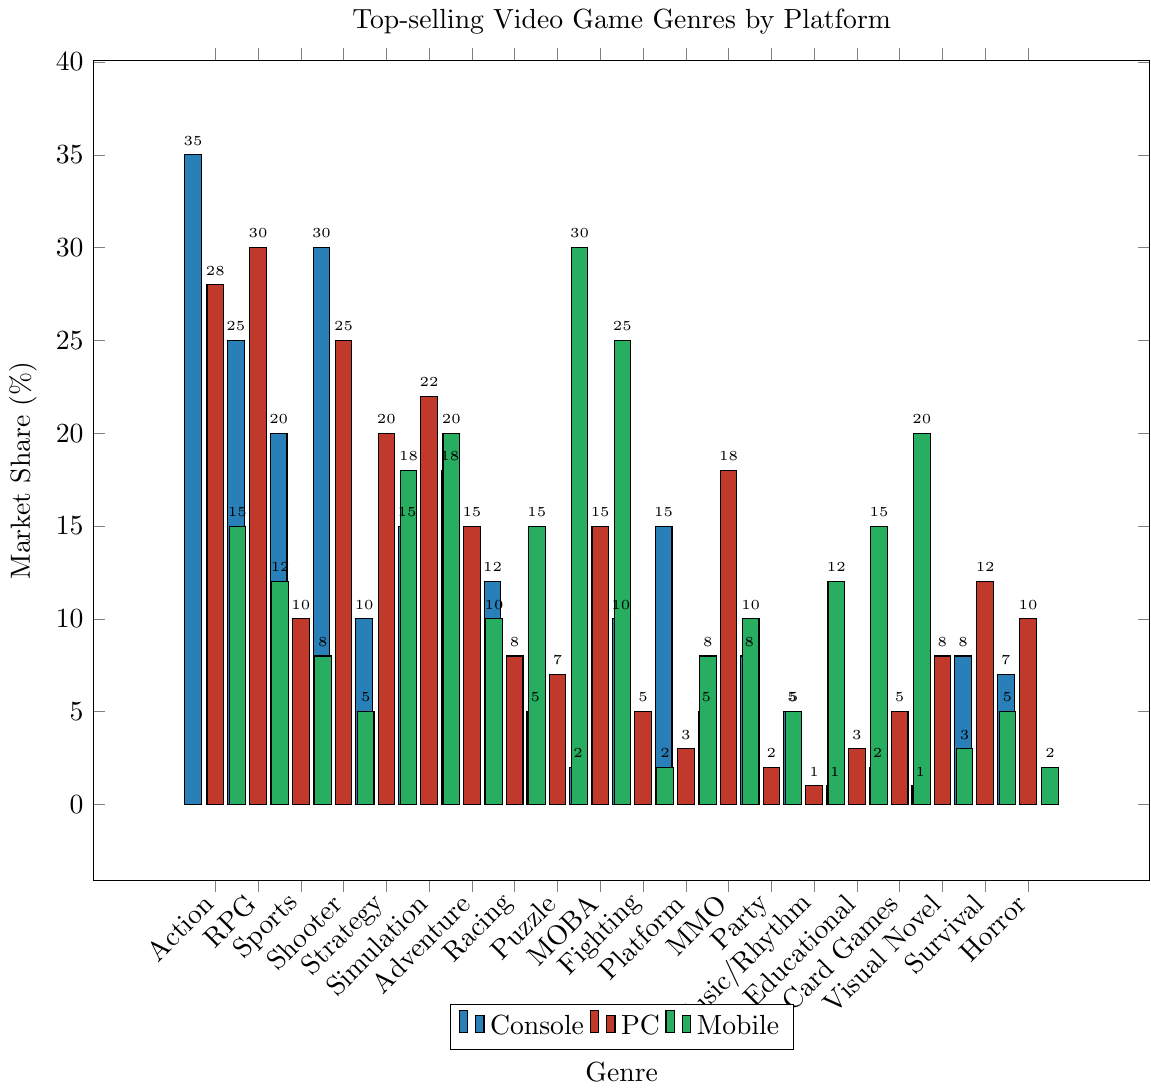What's the difference in market share for the "Action" genre between Console and Mobile platforms? The market share for the "Action" genre on Console is 35%, while on Mobile it is 15%. The difference is calculated as 35% - 15%.
Answer: 20% Which genre has the highest market share on Mobile? By observing the heights of the bars for Mobile across all genres, "Puzzle" has the highest market share with 30%.
Answer: Puzzle How many genres have a higher market share on PC than on Console? By comparing the heights of the bars for PC and Console for each genre, the genres with a higher market share on PC are RPG, Strategy, Simulation, MMO, MOBA, Visual Novel, and Horror. The total count of these genres is 7.
Answer: 7 What's the average market share of the "Sports" genre across all platforms? The market shares for "Sports" on Console, PC, and Mobile are 20%, 10%, and 8% respectively. The average is calculated as (20 + 10 + 8) / 3.
Answer: 12.67% Is the market share of the "Fighting" genre on Console higher, lower, or equal to the share of the "MOBA" genre on Mobile? The market share for the "Fighting" genre on Console is 10%, while for the "MOBA" genre on Mobile it is 25%. Comparing these values, 10% is less than 25%.
Answer: Lower Which genre has the lowest market share on Console? By observing the heights of the bars for Console, "Educational" has the lowest market share at 1%.
Answer: Educational What is the sum of market shares of the "Simulation" genre on Console and PC? The market shares for "Simulation" on Console and PC are 15% and 22% respectively. The sum is calculated as 15% + 22%.
Answer: 37% For which genre is the difference in market share between Mobile and PC the greatest? By calculating the absolute differences for each genre, we find that "Puzzle" has a difference of 30% - 7% = 23%, which is the greatest among all genres.
Answer: Puzzle How many genres have an equal market share of 10% on PC? By observing the heights of the bars for PC, the genres "Sports" and "Horror" both have a market share of 10%. The total count is 2.
Answer: 2 What's the market share of the "Racing" genre on Mobile compared to PC? The market share for the "Racing" genre on Mobile is 15%, and on PC it is 8%, so 15% is higher than 8%.
Answer: Higher 